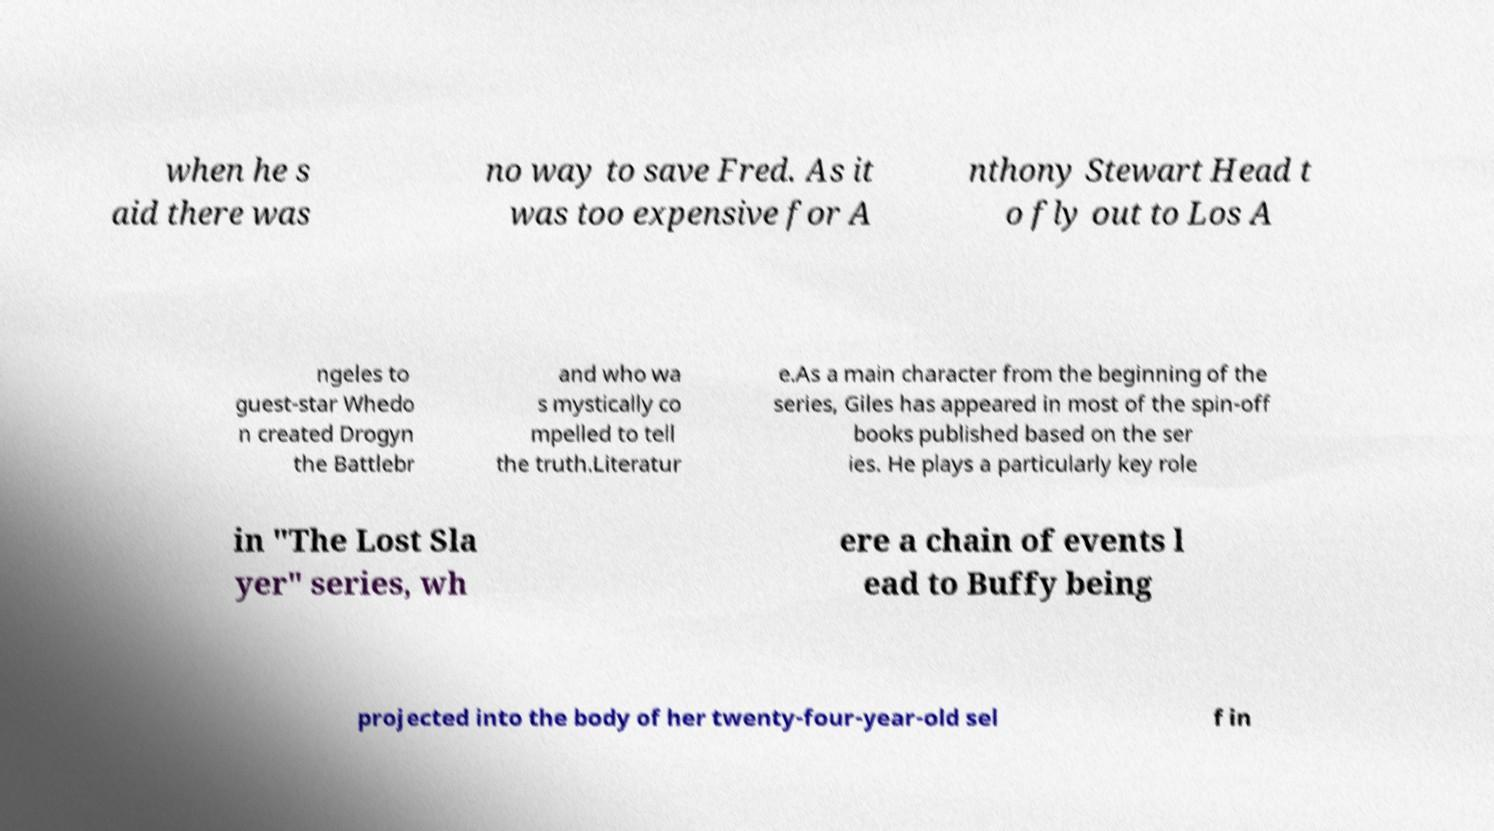Could you assist in decoding the text presented in this image and type it out clearly? when he s aid there was no way to save Fred. As it was too expensive for A nthony Stewart Head t o fly out to Los A ngeles to guest-star Whedo n created Drogyn the Battlebr and who wa s mystically co mpelled to tell the truth.Literatur e.As a main character from the beginning of the series, Giles has appeared in most of the spin-off books published based on the ser ies. He plays a particularly key role in "The Lost Sla yer" series, wh ere a chain of events l ead to Buffy being projected into the body of her twenty-four-year-old sel f in 